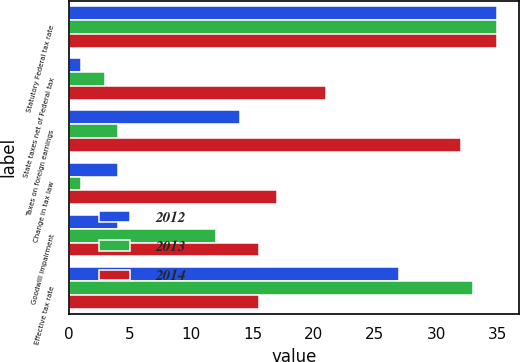<chart> <loc_0><loc_0><loc_500><loc_500><stacked_bar_chart><ecel><fcel>Statutory Federal tax rate<fcel>State taxes net of Federal tax<fcel>Taxes on foreign earnings<fcel>Change in tax law<fcel>Goodwill impairment<fcel>Effective tax rate<nl><fcel>2012<fcel>35<fcel>1<fcel>14<fcel>4<fcel>4<fcel>27<nl><fcel>2013<fcel>35<fcel>3<fcel>4<fcel>1<fcel>12<fcel>33<nl><fcel>2014<fcel>35<fcel>21<fcel>32<fcel>17<fcel>15.5<fcel>15.5<nl></chart> 